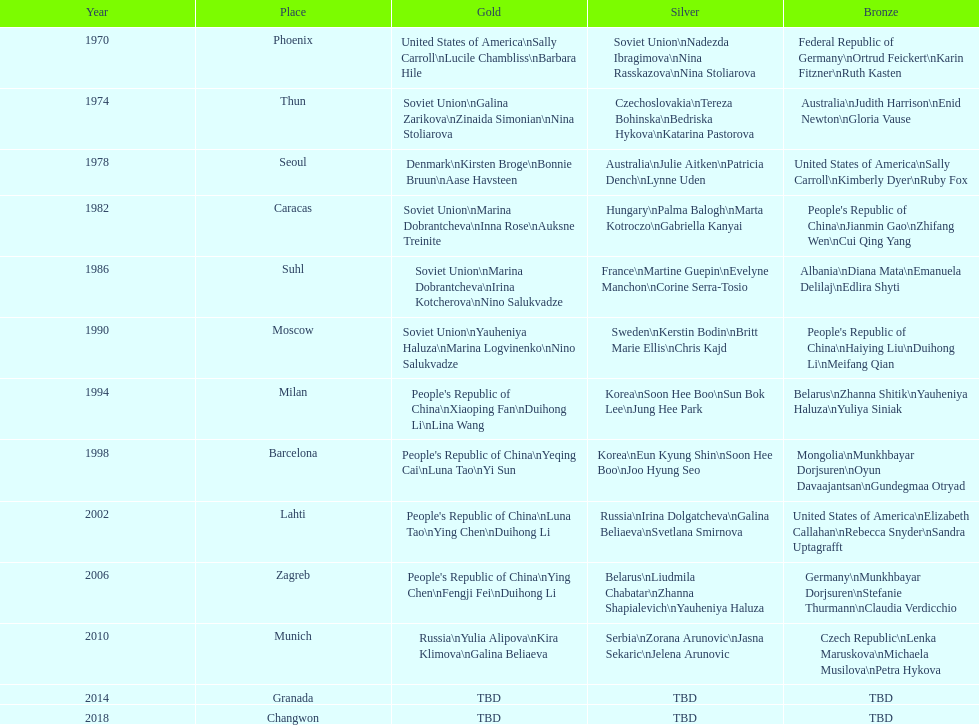What is the count of bronze medals won by germany? 2. Can you parse all the data within this table? {'header': ['Year', 'Place', 'Gold', 'Silver', 'Bronze'], 'rows': [['1970', 'Phoenix', 'United States of America\\nSally Carroll\\nLucile Chambliss\\nBarbara Hile', 'Soviet Union\\nNadezda Ibragimova\\nNina Rasskazova\\nNina Stoliarova', 'Federal Republic of Germany\\nOrtrud Feickert\\nKarin Fitzner\\nRuth Kasten'], ['1974', 'Thun', 'Soviet Union\\nGalina Zarikova\\nZinaida Simonian\\nNina Stoliarova', 'Czechoslovakia\\nTereza Bohinska\\nBedriska Hykova\\nKatarina Pastorova', 'Australia\\nJudith Harrison\\nEnid Newton\\nGloria Vause'], ['1978', 'Seoul', 'Denmark\\nKirsten Broge\\nBonnie Bruun\\nAase Havsteen', 'Australia\\nJulie Aitken\\nPatricia Dench\\nLynne Uden', 'United States of America\\nSally Carroll\\nKimberly Dyer\\nRuby Fox'], ['1982', 'Caracas', 'Soviet Union\\nMarina Dobrantcheva\\nInna Rose\\nAuksne Treinite', 'Hungary\\nPalma Balogh\\nMarta Kotroczo\\nGabriella Kanyai', "People's Republic of China\\nJianmin Gao\\nZhifang Wen\\nCui Qing Yang"], ['1986', 'Suhl', 'Soviet Union\\nMarina Dobrantcheva\\nIrina Kotcherova\\nNino Salukvadze', 'France\\nMartine Guepin\\nEvelyne Manchon\\nCorine Serra-Tosio', 'Albania\\nDiana Mata\\nEmanuela Delilaj\\nEdlira Shyti'], ['1990', 'Moscow', 'Soviet Union\\nYauheniya Haluza\\nMarina Logvinenko\\nNino Salukvadze', 'Sweden\\nKerstin Bodin\\nBritt Marie Ellis\\nChris Kajd', "People's Republic of China\\nHaiying Liu\\nDuihong Li\\nMeifang Qian"], ['1994', 'Milan', "People's Republic of China\\nXiaoping Fan\\nDuihong Li\\nLina Wang", 'Korea\\nSoon Hee Boo\\nSun Bok Lee\\nJung Hee Park', 'Belarus\\nZhanna Shitik\\nYauheniya Haluza\\nYuliya Siniak'], ['1998', 'Barcelona', "People's Republic of China\\nYeqing Cai\\nLuna Tao\\nYi Sun", 'Korea\\nEun Kyung Shin\\nSoon Hee Boo\\nJoo Hyung Seo', 'Mongolia\\nMunkhbayar Dorjsuren\\nOyun Davaajantsan\\nGundegmaa Otryad'], ['2002', 'Lahti', "People's Republic of China\\nLuna Tao\\nYing Chen\\nDuihong Li", 'Russia\\nIrina Dolgatcheva\\nGalina Beliaeva\\nSvetlana Smirnova', 'United States of America\\nElizabeth Callahan\\nRebecca Snyder\\nSandra Uptagrafft'], ['2006', 'Zagreb', "People's Republic of China\\nYing Chen\\nFengji Fei\\nDuihong Li", 'Belarus\\nLiudmila Chabatar\\nZhanna Shapialevich\\nYauheniya Haluza', 'Germany\\nMunkhbayar Dorjsuren\\nStefanie Thurmann\\nClaudia Verdicchio'], ['2010', 'Munich', 'Russia\\nYulia Alipova\\nKira Klimova\\nGalina Beliaeva', 'Serbia\\nZorana Arunovic\\nJasna Sekaric\\nJelena Arunovic', 'Czech Republic\\nLenka Maruskova\\nMichaela Musilova\\nPetra Hykova'], ['2014', 'Granada', 'TBD', 'TBD', 'TBD'], ['2018', 'Changwon', 'TBD', 'TBD', 'TBD']]} 